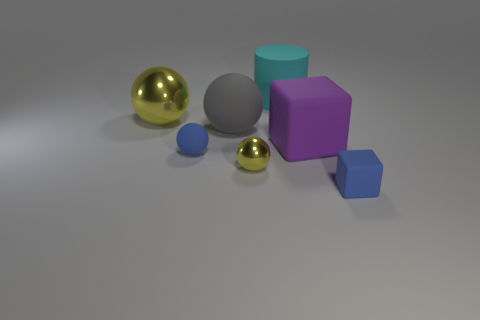What is the material of the yellow ball that is in front of the large ball to the left of the blue object left of the cyan rubber cylinder?
Provide a short and direct response. Metal. What number of matte objects are large purple cubes or large gray things?
Offer a terse response. 2. Do the tiny rubber cube and the large rubber block have the same color?
Provide a short and direct response. No. What number of objects are cyan cylinders or cubes that are to the left of the tiny matte block?
Provide a short and direct response. 2. There is a block that is behind the blue block; does it have the same size as the blue block?
Provide a succinct answer. No. What number of other objects are there of the same shape as the large cyan object?
Keep it short and to the point. 0. What number of purple things are large things or small blocks?
Give a very brief answer. 1. There is a big thing on the right side of the big cyan cylinder; does it have the same color as the tiny matte ball?
Offer a terse response. No. What is the shape of the cyan thing that is the same material as the big block?
Your response must be concise. Cylinder. There is a thing that is both to the right of the large cyan rubber object and behind the small cube; what is its color?
Offer a very short reply. Purple. 